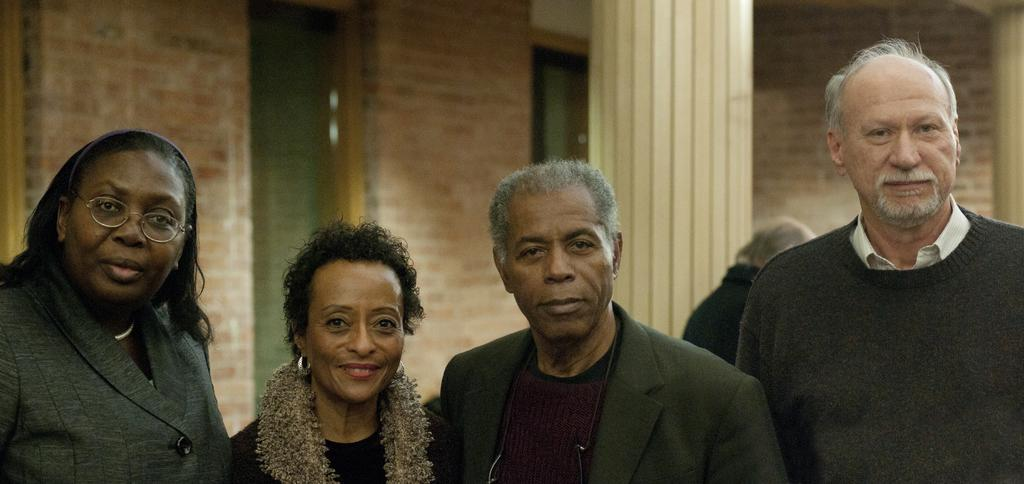How many people are present in the image? There are four people in the image, two women and two men. What are the people in the image doing? The people are standing. What can be seen in the background of the image? There is a wall and a pillar in the background of the image, as well as other people. What type of sweater is the judge wearing in the image? There is no judge or sweater present in the image. 